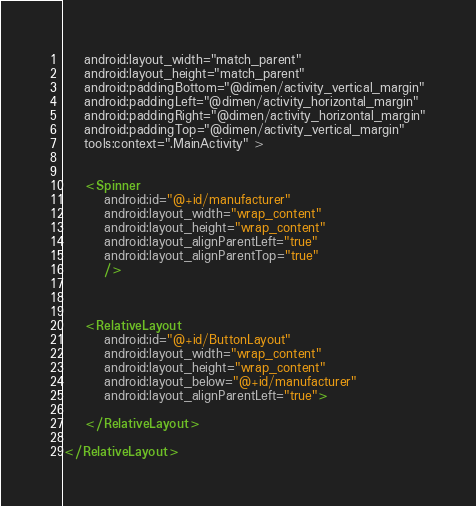<code> <loc_0><loc_0><loc_500><loc_500><_XML_>    android:layout_width="match_parent"
    android:layout_height="match_parent"
    android:paddingBottom="@dimen/activity_vertical_margin"
    android:paddingLeft="@dimen/activity_horizontal_margin"
    android:paddingRight="@dimen/activity_horizontal_margin"
    android:paddingTop="@dimen/activity_vertical_margin"
    tools:context=".MainActivity" >


    <Spinner
        android:id="@+id/manufacturer"
        android:layout_width="wrap_content"
        android:layout_height="wrap_content"
        android:layout_alignParentLeft="true"
        android:layout_alignParentTop="true"
        />

    
    
    <RelativeLayout
        android:id="@+id/ButtonLayout"
        android:layout_width="wrap_content"
        android:layout_height="wrap_content"
        android:layout_below="@+id/manufacturer"
        android:layout_alignParentLeft="true">

    </RelativeLayout>
    
</RelativeLayout></code> 